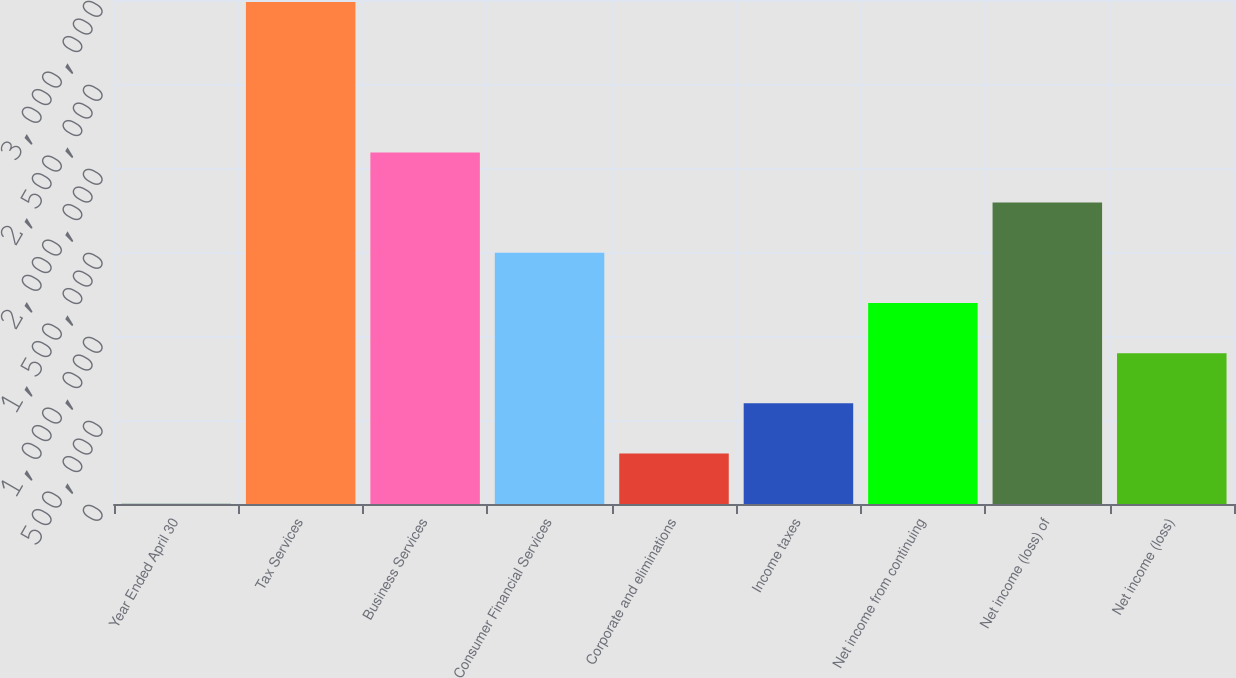<chart> <loc_0><loc_0><loc_500><loc_500><bar_chart><fcel>Year Ended April 30<fcel>Tax Services<fcel>Business Services<fcel>Consumer Financial Services<fcel>Corporate and eliminations<fcel>Income taxes<fcel>Net income from continuing<fcel>Net income (loss) of<fcel>Net income (loss)<nl><fcel>2008<fcel>2.98862e+06<fcel>2.09263e+06<fcel>1.49531e+06<fcel>300669<fcel>599330<fcel>1.19665e+06<fcel>1.79397e+06<fcel>897991<nl></chart> 